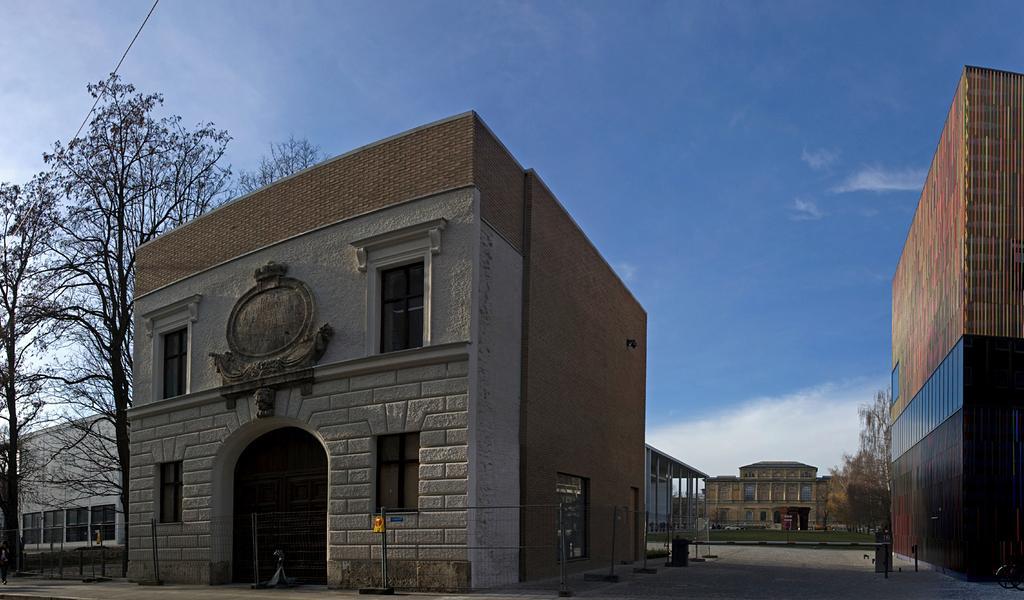Could you give a brief overview of what you see in this image? In this image I can see a building which is white and brown in color. I can see few poles, the metal fencing and few trees. In the background I can see few buildings, few trees and the sky. 